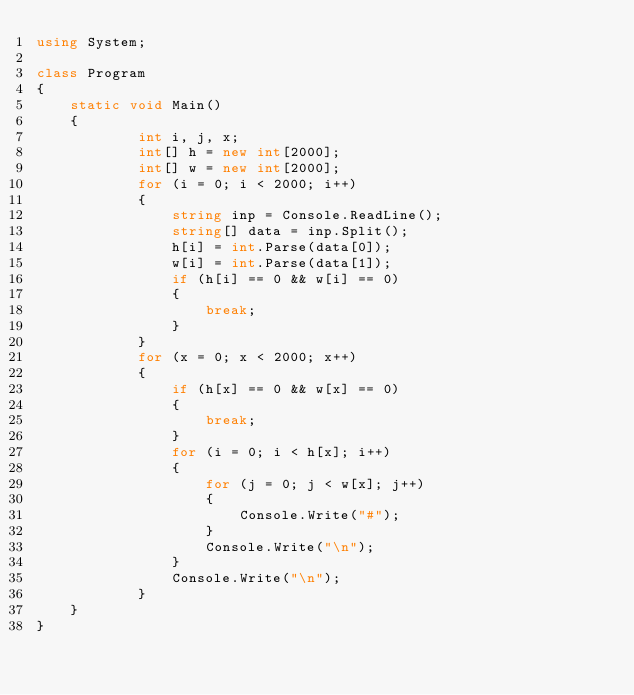<code> <loc_0><loc_0><loc_500><loc_500><_C#_>using System;

class Program
{
    static void Main()
    {
            int i, j, x;
            int[] h = new int[2000];
            int[] w = new int[2000];
            for (i = 0; i < 2000; i++)
            {
                string inp = Console.ReadLine();
                string[] data = inp.Split();
                h[i] = int.Parse(data[0]);
                w[i] = int.Parse(data[1]);
                if (h[i] == 0 && w[i] == 0)
                {
                    break;
                }
            }
            for (x = 0; x < 2000; x++)
            {
                if (h[x] == 0 && w[x] == 0)
                {
                    break;
                }
                for (i = 0; i < h[x]; i++)
                {
                    for (j = 0; j < w[x]; j++)
                    {
                        Console.Write("#");
                    }
                    Console.Write("\n");
                }
                Console.Write("\n");
            }
    }
}
</code> 